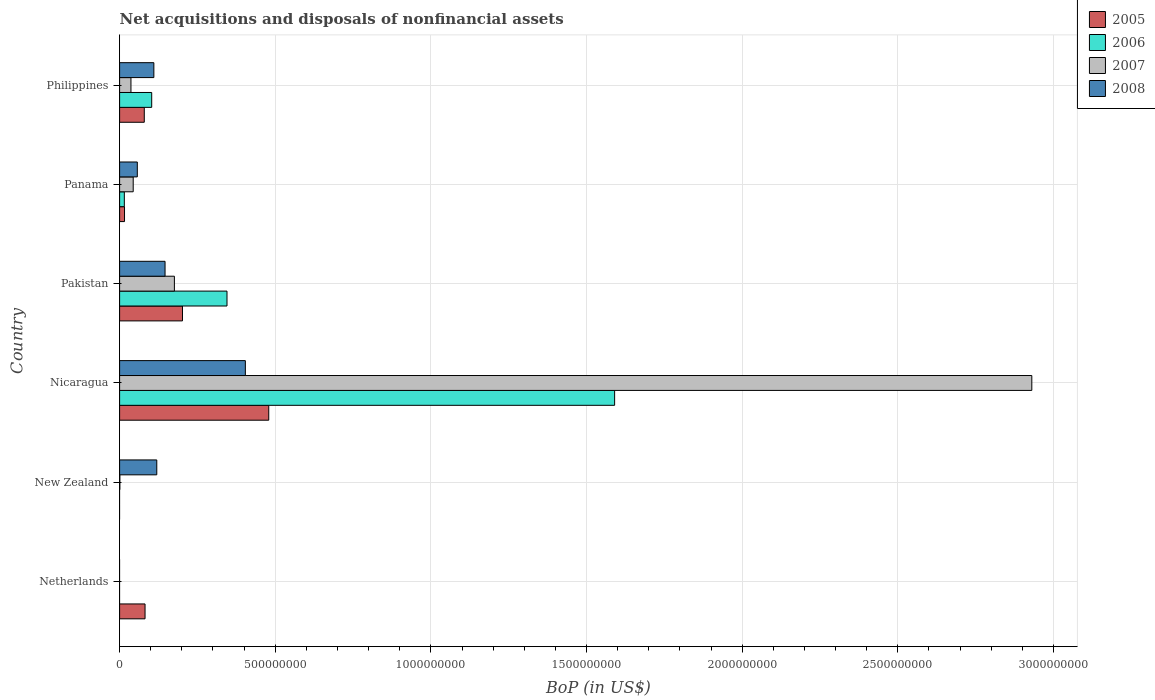Are the number of bars per tick equal to the number of legend labels?
Keep it short and to the point. No. Are the number of bars on each tick of the Y-axis equal?
Provide a short and direct response. No. How many bars are there on the 1st tick from the bottom?
Offer a terse response. 1. What is the label of the 6th group of bars from the top?
Offer a terse response. Netherlands. What is the Balance of Payments in 2008 in Nicaragua?
Provide a short and direct response. 4.04e+08. Across all countries, what is the maximum Balance of Payments in 2006?
Make the answer very short. 1.59e+09. Across all countries, what is the minimum Balance of Payments in 2005?
Offer a terse response. 0. In which country was the Balance of Payments in 2005 maximum?
Provide a short and direct response. Nicaragua. What is the total Balance of Payments in 2006 in the graph?
Offer a very short reply. 2.05e+09. What is the difference between the Balance of Payments in 2005 in Pakistan and that in Philippines?
Your answer should be very brief. 1.23e+08. What is the difference between the Balance of Payments in 2005 in Pakistan and the Balance of Payments in 2008 in New Zealand?
Offer a terse response. 8.26e+07. What is the average Balance of Payments in 2007 per country?
Give a very brief answer. 5.31e+08. What is the difference between the Balance of Payments in 2008 and Balance of Payments in 2007 in Nicaragua?
Make the answer very short. -2.53e+09. In how many countries, is the Balance of Payments in 2005 greater than 2200000000 US$?
Give a very brief answer. 0. What is the ratio of the Balance of Payments in 2005 in Netherlands to that in Panama?
Ensure brevity in your answer.  5.17. What is the difference between the highest and the second highest Balance of Payments in 2006?
Make the answer very short. 1.25e+09. What is the difference between the highest and the lowest Balance of Payments in 2005?
Ensure brevity in your answer.  4.79e+08. In how many countries, is the Balance of Payments in 2005 greater than the average Balance of Payments in 2005 taken over all countries?
Offer a very short reply. 2. Is the sum of the Balance of Payments in 2008 in Nicaragua and Pakistan greater than the maximum Balance of Payments in 2007 across all countries?
Offer a terse response. No. Is it the case that in every country, the sum of the Balance of Payments in 2006 and Balance of Payments in 2008 is greater than the sum of Balance of Payments in 2005 and Balance of Payments in 2007?
Your response must be concise. No. Is it the case that in every country, the sum of the Balance of Payments in 2008 and Balance of Payments in 2005 is greater than the Balance of Payments in 2006?
Your answer should be compact. No. How many bars are there?
Offer a terse response. 19. How many countries are there in the graph?
Offer a very short reply. 6. Does the graph contain any zero values?
Your response must be concise. Yes. Does the graph contain grids?
Your response must be concise. Yes. Where does the legend appear in the graph?
Your response must be concise. Top right. How many legend labels are there?
Your answer should be very brief. 4. What is the title of the graph?
Provide a succinct answer. Net acquisitions and disposals of nonfinancial assets. What is the label or title of the X-axis?
Provide a succinct answer. BoP (in US$). What is the BoP (in US$) in 2005 in Netherlands?
Ensure brevity in your answer.  8.17e+07. What is the BoP (in US$) in 2008 in Netherlands?
Your answer should be very brief. 0. What is the BoP (in US$) of 2006 in New Zealand?
Keep it short and to the point. 0. What is the BoP (in US$) of 2007 in New Zealand?
Ensure brevity in your answer.  7.64e+05. What is the BoP (in US$) in 2008 in New Zealand?
Your answer should be very brief. 1.19e+08. What is the BoP (in US$) of 2005 in Nicaragua?
Keep it short and to the point. 4.79e+08. What is the BoP (in US$) in 2006 in Nicaragua?
Provide a short and direct response. 1.59e+09. What is the BoP (in US$) of 2007 in Nicaragua?
Keep it short and to the point. 2.93e+09. What is the BoP (in US$) in 2008 in Nicaragua?
Make the answer very short. 4.04e+08. What is the BoP (in US$) of 2005 in Pakistan?
Offer a terse response. 2.02e+08. What is the BoP (in US$) of 2006 in Pakistan?
Your answer should be compact. 3.45e+08. What is the BoP (in US$) in 2007 in Pakistan?
Make the answer very short. 1.76e+08. What is the BoP (in US$) in 2008 in Pakistan?
Give a very brief answer. 1.46e+08. What is the BoP (in US$) in 2005 in Panama?
Provide a short and direct response. 1.58e+07. What is the BoP (in US$) in 2006 in Panama?
Your answer should be compact. 1.52e+07. What is the BoP (in US$) of 2007 in Panama?
Make the answer very short. 4.37e+07. What is the BoP (in US$) in 2008 in Panama?
Your response must be concise. 5.69e+07. What is the BoP (in US$) in 2005 in Philippines?
Offer a terse response. 7.93e+07. What is the BoP (in US$) in 2006 in Philippines?
Your response must be concise. 1.03e+08. What is the BoP (in US$) of 2007 in Philippines?
Make the answer very short. 3.64e+07. What is the BoP (in US$) of 2008 in Philippines?
Give a very brief answer. 1.10e+08. Across all countries, what is the maximum BoP (in US$) of 2005?
Make the answer very short. 4.79e+08. Across all countries, what is the maximum BoP (in US$) in 2006?
Provide a short and direct response. 1.59e+09. Across all countries, what is the maximum BoP (in US$) in 2007?
Provide a succinct answer. 2.93e+09. Across all countries, what is the maximum BoP (in US$) in 2008?
Your answer should be very brief. 4.04e+08. Across all countries, what is the minimum BoP (in US$) of 2007?
Keep it short and to the point. 0. Across all countries, what is the minimum BoP (in US$) in 2008?
Offer a very short reply. 0. What is the total BoP (in US$) of 2005 in the graph?
Your answer should be very brief. 8.58e+08. What is the total BoP (in US$) of 2006 in the graph?
Your response must be concise. 2.05e+09. What is the total BoP (in US$) in 2007 in the graph?
Provide a short and direct response. 3.19e+09. What is the total BoP (in US$) of 2008 in the graph?
Your answer should be compact. 8.36e+08. What is the difference between the BoP (in US$) of 2005 in Netherlands and that in Nicaragua?
Keep it short and to the point. -3.97e+08. What is the difference between the BoP (in US$) in 2005 in Netherlands and that in Pakistan?
Give a very brief answer. -1.20e+08. What is the difference between the BoP (in US$) of 2005 in Netherlands and that in Panama?
Your response must be concise. 6.59e+07. What is the difference between the BoP (in US$) in 2005 in Netherlands and that in Philippines?
Provide a short and direct response. 2.45e+06. What is the difference between the BoP (in US$) of 2007 in New Zealand and that in Nicaragua?
Offer a very short reply. -2.93e+09. What is the difference between the BoP (in US$) in 2008 in New Zealand and that in Nicaragua?
Provide a succinct answer. -2.85e+08. What is the difference between the BoP (in US$) of 2007 in New Zealand and that in Pakistan?
Make the answer very short. -1.75e+08. What is the difference between the BoP (in US$) of 2008 in New Zealand and that in Pakistan?
Your answer should be compact. -2.66e+07. What is the difference between the BoP (in US$) of 2007 in New Zealand and that in Panama?
Your response must be concise. -4.29e+07. What is the difference between the BoP (in US$) in 2008 in New Zealand and that in Panama?
Your response must be concise. 6.25e+07. What is the difference between the BoP (in US$) of 2007 in New Zealand and that in Philippines?
Make the answer very short. -3.57e+07. What is the difference between the BoP (in US$) in 2008 in New Zealand and that in Philippines?
Make the answer very short. 9.38e+06. What is the difference between the BoP (in US$) of 2005 in Nicaragua and that in Pakistan?
Provide a succinct answer. 2.77e+08. What is the difference between the BoP (in US$) of 2006 in Nicaragua and that in Pakistan?
Make the answer very short. 1.25e+09. What is the difference between the BoP (in US$) in 2007 in Nicaragua and that in Pakistan?
Keep it short and to the point. 2.75e+09. What is the difference between the BoP (in US$) of 2008 in Nicaragua and that in Pakistan?
Ensure brevity in your answer.  2.58e+08. What is the difference between the BoP (in US$) in 2005 in Nicaragua and that in Panama?
Make the answer very short. 4.63e+08. What is the difference between the BoP (in US$) of 2006 in Nicaragua and that in Panama?
Your answer should be very brief. 1.58e+09. What is the difference between the BoP (in US$) in 2007 in Nicaragua and that in Panama?
Ensure brevity in your answer.  2.89e+09. What is the difference between the BoP (in US$) in 2008 in Nicaragua and that in Panama?
Make the answer very short. 3.47e+08. What is the difference between the BoP (in US$) of 2005 in Nicaragua and that in Philippines?
Make the answer very short. 4.00e+08. What is the difference between the BoP (in US$) of 2006 in Nicaragua and that in Philippines?
Your response must be concise. 1.49e+09. What is the difference between the BoP (in US$) in 2007 in Nicaragua and that in Philippines?
Your response must be concise. 2.89e+09. What is the difference between the BoP (in US$) of 2008 in Nicaragua and that in Philippines?
Your answer should be very brief. 2.94e+08. What is the difference between the BoP (in US$) in 2005 in Pakistan and that in Panama?
Ensure brevity in your answer.  1.86e+08. What is the difference between the BoP (in US$) in 2006 in Pakistan and that in Panama?
Keep it short and to the point. 3.30e+08. What is the difference between the BoP (in US$) of 2007 in Pakistan and that in Panama?
Offer a very short reply. 1.32e+08. What is the difference between the BoP (in US$) of 2008 in Pakistan and that in Panama?
Keep it short and to the point. 8.91e+07. What is the difference between the BoP (in US$) of 2005 in Pakistan and that in Philippines?
Provide a short and direct response. 1.23e+08. What is the difference between the BoP (in US$) of 2006 in Pakistan and that in Philippines?
Your answer should be very brief. 2.42e+08. What is the difference between the BoP (in US$) of 2007 in Pakistan and that in Philippines?
Provide a short and direct response. 1.40e+08. What is the difference between the BoP (in US$) of 2008 in Pakistan and that in Philippines?
Make the answer very short. 3.59e+07. What is the difference between the BoP (in US$) of 2005 in Panama and that in Philippines?
Make the answer very short. -6.35e+07. What is the difference between the BoP (in US$) of 2006 in Panama and that in Philippines?
Your answer should be compact. -8.79e+07. What is the difference between the BoP (in US$) in 2007 in Panama and that in Philippines?
Keep it short and to the point. 7.26e+06. What is the difference between the BoP (in US$) of 2008 in Panama and that in Philippines?
Your response must be concise. -5.32e+07. What is the difference between the BoP (in US$) in 2005 in Netherlands and the BoP (in US$) in 2007 in New Zealand?
Offer a terse response. 8.10e+07. What is the difference between the BoP (in US$) of 2005 in Netherlands and the BoP (in US$) of 2008 in New Zealand?
Your answer should be very brief. -3.77e+07. What is the difference between the BoP (in US$) of 2005 in Netherlands and the BoP (in US$) of 2006 in Nicaragua?
Make the answer very short. -1.51e+09. What is the difference between the BoP (in US$) of 2005 in Netherlands and the BoP (in US$) of 2007 in Nicaragua?
Provide a short and direct response. -2.85e+09. What is the difference between the BoP (in US$) of 2005 in Netherlands and the BoP (in US$) of 2008 in Nicaragua?
Make the answer very short. -3.22e+08. What is the difference between the BoP (in US$) of 2005 in Netherlands and the BoP (in US$) of 2006 in Pakistan?
Keep it short and to the point. -2.63e+08. What is the difference between the BoP (in US$) of 2005 in Netherlands and the BoP (in US$) of 2007 in Pakistan?
Your answer should be very brief. -9.43e+07. What is the difference between the BoP (in US$) of 2005 in Netherlands and the BoP (in US$) of 2008 in Pakistan?
Ensure brevity in your answer.  -6.43e+07. What is the difference between the BoP (in US$) in 2005 in Netherlands and the BoP (in US$) in 2006 in Panama?
Your response must be concise. 6.65e+07. What is the difference between the BoP (in US$) in 2005 in Netherlands and the BoP (in US$) in 2007 in Panama?
Your answer should be compact. 3.80e+07. What is the difference between the BoP (in US$) of 2005 in Netherlands and the BoP (in US$) of 2008 in Panama?
Give a very brief answer. 2.48e+07. What is the difference between the BoP (in US$) in 2005 in Netherlands and the BoP (in US$) in 2006 in Philippines?
Ensure brevity in your answer.  -2.14e+07. What is the difference between the BoP (in US$) in 2005 in Netherlands and the BoP (in US$) in 2007 in Philippines?
Offer a very short reply. 4.53e+07. What is the difference between the BoP (in US$) of 2005 in Netherlands and the BoP (in US$) of 2008 in Philippines?
Offer a terse response. -2.83e+07. What is the difference between the BoP (in US$) of 2007 in New Zealand and the BoP (in US$) of 2008 in Nicaragua?
Offer a terse response. -4.03e+08. What is the difference between the BoP (in US$) of 2007 in New Zealand and the BoP (in US$) of 2008 in Pakistan?
Your answer should be very brief. -1.45e+08. What is the difference between the BoP (in US$) of 2007 in New Zealand and the BoP (in US$) of 2008 in Panama?
Make the answer very short. -5.61e+07. What is the difference between the BoP (in US$) of 2007 in New Zealand and the BoP (in US$) of 2008 in Philippines?
Ensure brevity in your answer.  -1.09e+08. What is the difference between the BoP (in US$) in 2005 in Nicaragua and the BoP (in US$) in 2006 in Pakistan?
Keep it short and to the point. 1.34e+08. What is the difference between the BoP (in US$) in 2005 in Nicaragua and the BoP (in US$) in 2007 in Pakistan?
Keep it short and to the point. 3.03e+08. What is the difference between the BoP (in US$) in 2005 in Nicaragua and the BoP (in US$) in 2008 in Pakistan?
Keep it short and to the point. 3.33e+08. What is the difference between the BoP (in US$) in 2006 in Nicaragua and the BoP (in US$) in 2007 in Pakistan?
Keep it short and to the point. 1.41e+09. What is the difference between the BoP (in US$) of 2006 in Nicaragua and the BoP (in US$) of 2008 in Pakistan?
Keep it short and to the point. 1.44e+09. What is the difference between the BoP (in US$) in 2007 in Nicaragua and the BoP (in US$) in 2008 in Pakistan?
Give a very brief answer. 2.78e+09. What is the difference between the BoP (in US$) of 2005 in Nicaragua and the BoP (in US$) of 2006 in Panama?
Your response must be concise. 4.64e+08. What is the difference between the BoP (in US$) in 2005 in Nicaragua and the BoP (in US$) in 2007 in Panama?
Make the answer very short. 4.35e+08. What is the difference between the BoP (in US$) of 2005 in Nicaragua and the BoP (in US$) of 2008 in Panama?
Your answer should be compact. 4.22e+08. What is the difference between the BoP (in US$) of 2006 in Nicaragua and the BoP (in US$) of 2007 in Panama?
Keep it short and to the point. 1.55e+09. What is the difference between the BoP (in US$) of 2006 in Nicaragua and the BoP (in US$) of 2008 in Panama?
Your answer should be compact. 1.53e+09. What is the difference between the BoP (in US$) of 2007 in Nicaragua and the BoP (in US$) of 2008 in Panama?
Give a very brief answer. 2.87e+09. What is the difference between the BoP (in US$) in 2005 in Nicaragua and the BoP (in US$) in 2006 in Philippines?
Make the answer very short. 3.76e+08. What is the difference between the BoP (in US$) of 2005 in Nicaragua and the BoP (in US$) of 2007 in Philippines?
Your answer should be compact. 4.43e+08. What is the difference between the BoP (in US$) in 2005 in Nicaragua and the BoP (in US$) in 2008 in Philippines?
Your answer should be compact. 3.69e+08. What is the difference between the BoP (in US$) in 2006 in Nicaragua and the BoP (in US$) in 2007 in Philippines?
Your response must be concise. 1.55e+09. What is the difference between the BoP (in US$) of 2006 in Nicaragua and the BoP (in US$) of 2008 in Philippines?
Keep it short and to the point. 1.48e+09. What is the difference between the BoP (in US$) in 2007 in Nicaragua and the BoP (in US$) in 2008 in Philippines?
Ensure brevity in your answer.  2.82e+09. What is the difference between the BoP (in US$) of 2005 in Pakistan and the BoP (in US$) of 2006 in Panama?
Give a very brief answer. 1.87e+08. What is the difference between the BoP (in US$) of 2005 in Pakistan and the BoP (in US$) of 2007 in Panama?
Provide a short and direct response. 1.58e+08. What is the difference between the BoP (in US$) of 2005 in Pakistan and the BoP (in US$) of 2008 in Panama?
Make the answer very short. 1.45e+08. What is the difference between the BoP (in US$) in 2006 in Pakistan and the BoP (in US$) in 2007 in Panama?
Your answer should be compact. 3.01e+08. What is the difference between the BoP (in US$) in 2006 in Pakistan and the BoP (in US$) in 2008 in Panama?
Give a very brief answer. 2.88e+08. What is the difference between the BoP (in US$) in 2007 in Pakistan and the BoP (in US$) in 2008 in Panama?
Provide a short and direct response. 1.19e+08. What is the difference between the BoP (in US$) in 2005 in Pakistan and the BoP (in US$) in 2006 in Philippines?
Your response must be concise. 9.89e+07. What is the difference between the BoP (in US$) in 2005 in Pakistan and the BoP (in US$) in 2007 in Philippines?
Offer a terse response. 1.66e+08. What is the difference between the BoP (in US$) of 2005 in Pakistan and the BoP (in US$) of 2008 in Philippines?
Give a very brief answer. 9.19e+07. What is the difference between the BoP (in US$) of 2006 in Pakistan and the BoP (in US$) of 2007 in Philippines?
Provide a succinct answer. 3.09e+08. What is the difference between the BoP (in US$) in 2006 in Pakistan and the BoP (in US$) in 2008 in Philippines?
Ensure brevity in your answer.  2.35e+08. What is the difference between the BoP (in US$) in 2007 in Pakistan and the BoP (in US$) in 2008 in Philippines?
Provide a short and direct response. 6.59e+07. What is the difference between the BoP (in US$) in 2005 in Panama and the BoP (in US$) in 2006 in Philippines?
Your answer should be very brief. -8.73e+07. What is the difference between the BoP (in US$) in 2005 in Panama and the BoP (in US$) in 2007 in Philippines?
Keep it short and to the point. -2.06e+07. What is the difference between the BoP (in US$) of 2005 in Panama and the BoP (in US$) of 2008 in Philippines?
Give a very brief answer. -9.43e+07. What is the difference between the BoP (in US$) in 2006 in Panama and the BoP (in US$) in 2007 in Philippines?
Keep it short and to the point. -2.12e+07. What is the difference between the BoP (in US$) in 2006 in Panama and the BoP (in US$) in 2008 in Philippines?
Offer a very short reply. -9.49e+07. What is the difference between the BoP (in US$) in 2007 in Panama and the BoP (in US$) in 2008 in Philippines?
Offer a very short reply. -6.64e+07. What is the average BoP (in US$) of 2005 per country?
Keep it short and to the point. 1.43e+08. What is the average BoP (in US$) in 2006 per country?
Make the answer very short. 3.42e+08. What is the average BoP (in US$) in 2007 per country?
Your answer should be compact. 5.31e+08. What is the average BoP (in US$) of 2008 per country?
Provide a short and direct response. 1.39e+08. What is the difference between the BoP (in US$) of 2007 and BoP (in US$) of 2008 in New Zealand?
Keep it short and to the point. -1.19e+08. What is the difference between the BoP (in US$) in 2005 and BoP (in US$) in 2006 in Nicaragua?
Provide a succinct answer. -1.11e+09. What is the difference between the BoP (in US$) in 2005 and BoP (in US$) in 2007 in Nicaragua?
Provide a short and direct response. -2.45e+09. What is the difference between the BoP (in US$) in 2005 and BoP (in US$) in 2008 in Nicaragua?
Make the answer very short. 7.51e+07. What is the difference between the BoP (in US$) of 2006 and BoP (in US$) of 2007 in Nicaragua?
Your response must be concise. -1.34e+09. What is the difference between the BoP (in US$) in 2006 and BoP (in US$) in 2008 in Nicaragua?
Your response must be concise. 1.19e+09. What is the difference between the BoP (in US$) in 2007 and BoP (in US$) in 2008 in Nicaragua?
Offer a very short reply. 2.53e+09. What is the difference between the BoP (in US$) in 2005 and BoP (in US$) in 2006 in Pakistan?
Provide a short and direct response. -1.43e+08. What is the difference between the BoP (in US$) in 2005 and BoP (in US$) in 2007 in Pakistan?
Provide a short and direct response. 2.60e+07. What is the difference between the BoP (in US$) in 2005 and BoP (in US$) in 2008 in Pakistan?
Offer a very short reply. 5.60e+07. What is the difference between the BoP (in US$) of 2006 and BoP (in US$) of 2007 in Pakistan?
Ensure brevity in your answer.  1.69e+08. What is the difference between the BoP (in US$) in 2006 and BoP (in US$) in 2008 in Pakistan?
Your response must be concise. 1.99e+08. What is the difference between the BoP (in US$) in 2007 and BoP (in US$) in 2008 in Pakistan?
Provide a succinct answer. 3.00e+07. What is the difference between the BoP (in US$) of 2005 and BoP (in US$) of 2006 in Panama?
Offer a terse response. 6.00e+05. What is the difference between the BoP (in US$) of 2005 and BoP (in US$) of 2007 in Panama?
Ensure brevity in your answer.  -2.79e+07. What is the difference between the BoP (in US$) in 2005 and BoP (in US$) in 2008 in Panama?
Your response must be concise. -4.11e+07. What is the difference between the BoP (in US$) in 2006 and BoP (in US$) in 2007 in Panama?
Provide a short and direct response. -2.85e+07. What is the difference between the BoP (in US$) of 2006 and BoP (in US$) of 2008 in Panama?
Offer a terse response. -4.17e+07. What is the difference between the BoP (in US$) of 2007 and BoP (in US$) of 2008 in Panama?
Offer a very short reply. -1.32e+07. What is the difference between the BoP (in US$) in 2005 and BoP (in US$) in 2006 in Philippines?
Ensure brevity in your answer.  -2.38e+07. What is the difference between the BoP (in US$) in 2005 and BoP (in US$) in 2007 in Philippines?
Give a very brief answer. 4.28e+07. What is the difference between the BoP (in US$) in 2005 and BoP (in US$) in 2008 in Philippines?
Provide a short and direct response. -3.08e+07. What is the difference between the BoP (in US$) of 2006 and BoP (in US$) of 2007 in Philippines?
Your response must be concise. 6.67e+07. What is the difference between the BoP (in US$) of 2006 and BoP (in US$) of 2008 in Philippines?
Keep it short and to the point. -6.96e+06. What is the difference between the BoP (in US$) of 2007 and BoP (in US$) of 2008 in Philippines?
Your answer should be very brief. -7.36e+07. What is the ratio of the BoP (in US$) of 2005 in Netherlands to that in Nicaragua?
Offer a terse response. 0.17. What is the ratio of the BoP (in US$) of 2005 in Netherlands to that in Pakistan?
Give a very brief answer. 0.4. What is the ratio of the BoP (in US$) in 2005 in Netherlands to that in Panama?
Provide a succinct answer. 5.17. What is the ratio of the BoP (in US$) in 2005 in Netherlands to that in Philippines?
Your answer should be compact. 1.03. What is the ratio of the BoP (in US$) of 2008 in New Zealand to that in Nicaragua?
Provide a short and direct response. 0.3. What is the ratio of the BoP (in US$) in 2007 in New Zealand to that in Pakistan?
Your answer should be compact. 0. What is the ratio of the BoP (in US$) of 2008 in New Zealand to that in Pakistan?
Provide a succinct answer. 0.82. What is the ratio of the BoP (in US$) in 2007 in New Zealand to that in Panama?
Your answer should be compact. 0.02. What is the ratio of the BoP (in US$) in 2008 in New Zealand to that in Panama?
Provide a short and direct response. 2.1. What is the ratio of the BoP (in US$) of 2007 in New Zealand to that in Philippines?
Your answer should be compact. 0.02. What is the ratio of the BoP (in US$) of 2008 in New Zealand to that in Philippines?
Provide a short and direct response. 1.09. What is the ratio of the BoP (in US$) in 2005 in Nicaragua to that in Pakistan?
Give a very brief answer. 2.37. What is the ratio of the BoP (in US$) of 2006 in Nicaragua to that in Pakistan?
Provide a succinct answer. 4.61. What is the ratio of the BoP (in US$) in 2007 in Nicaragua to that in Pakistan?
Ensure brevity in your answer.  16.65. What is the ratio of the BoP (in US$) in 2008 in Nicaragua to that in Pakistan?
Provide a succinct answer. 2.77. What is the ratio of the BoP (in US$) of 2005 in Nicaragua to that in Panama?
Your answer should be compact. 30.32. What is the ratio of the BoP (in US$) in 2006 in Nicaragua to that in Panama?
Your answer should be very brief. 104.62. What is the ratio of the BoP (in US$) of 2007 in Nicaragua to that in Panama?
Offer a very short reply. 67.06. What is the ratio of the BoP (in US$) in 2008 in Nicaragua to that in Panama?
Offer a terse response. 7.1. What is the ratio of the BoP (in US$) in 2005 in Nicaragua to that in Philippines?
Ensure brevity in your answer.  6.04. What is the ratio of the BoP (in US$) in 2006 in Nicaragua to that in Philippines?
Make the answer very short. 15.42. What is the ratio of the BoP (in US$) of 2007 in Nicaragua to that in Philippines?
Provide a succinct answer. 80.41. What is the ratio of the BoP (in US$) of 2008 in Nicaragua to that in Philippines?
Keep it short and to the point. 3.67. What is the ratio of the BoP (in US$) in 2005 in Pakistan to that in Panama?
Ensure brevity in your answer.  12.78. What is the ratio of the BoP (in US$) in 2006 in Pakistan to that in Panama?
Offer a very short reply. 22.7. What is the ratio of the BoP (in US$) of 2007 in Pakistan to that in Panama?
Keep it short and to the point. 4.03. What is the ratio of the BoP (in US$) in 2008 in Pakistan to that in Panama?
Your answer should be compact. 2.57. What is the ratio of the BoP (in US$) in 2005 in Pakistan to that in Philippines?
Give a very brief answer. 2.55. What is the ratio of the BoP (in US$) in 2006 in Pakistan to that in Philippines?
Your answer should be compact. 3.35. What is the ratio of the BoP (in US$) of 2007 in Pakistan to that in Philippines?
Your response must be concise. 4.83. What is the ratio of the BoP (in US$) in 2008 in Pakistan to that in Philippines?
Your answer should be compact. 1.33. What is the ratio of the BoP (in US$) of 2005 in Panama to that in Philippines?
Offer a very short reply. 0.2. What is the ratio of the BoP (in US$) of 2006 in Panama to that in Philippines?
Keep it short and to the point. 0.15. What is the ratio of the BoP (in US$) in 2007 in Panama to that in Philippines?
Your answer should be very brief. 1.2. What is the ratio of the BoP (in US$) of 2008 in Panama to that in Philippines?
Provide a succinct answer. 0.52. What is the difference between the highest and the second highest BoP (in US$) of 2005?
Your response must be concise. 2.77e+08. What is the difference between the highest and the second highest BoP (in US$) in 2006?
Offer a very short reply. 1.25e+09. What is the difference between the highest and the second highest BoP (in US$) of 2007?
Make the answer very short. 2.75e+09. What is the difference between the highest and the second highest BoP (in US$) in 2008?
Ensure brevity in your answer.  2.58e+08. What is the difference between the highest and the lowest BoP (in US$) in 2005?
Make the answer very short. 4.79e+08. What is the difference between the highest and the lowest BoP (in US$) of 2006?
Your response must be concise. 1.59e+09. What is the difference between the highest and the lowest BoP (in US$) of 2007?
Give a very brief answer. 2.93e+09. What is the difference between the highest and the lowest BoP (in US$) in 2008?
Offer a very short reply. 4.04e+08. 